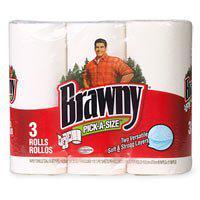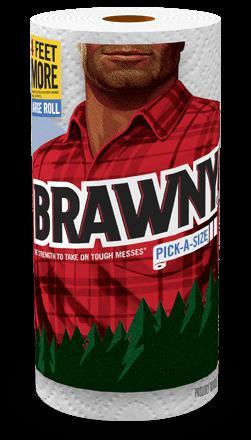The first image is the image on the left, the second image is the image on the right. Analyze the images presented: Is the assertion "There are at least six rolls of paper towels in the package on the left." valid? Answer yes or no. No. The first image is the image on the left, the second image is the image on the right. Evaluate the accuracy of this statement regarding the images: "At least one image contains a single upright paper towel roll in a wrapper that features a red plaid shirt.". Is it true? Answer yes or no. Yes. 